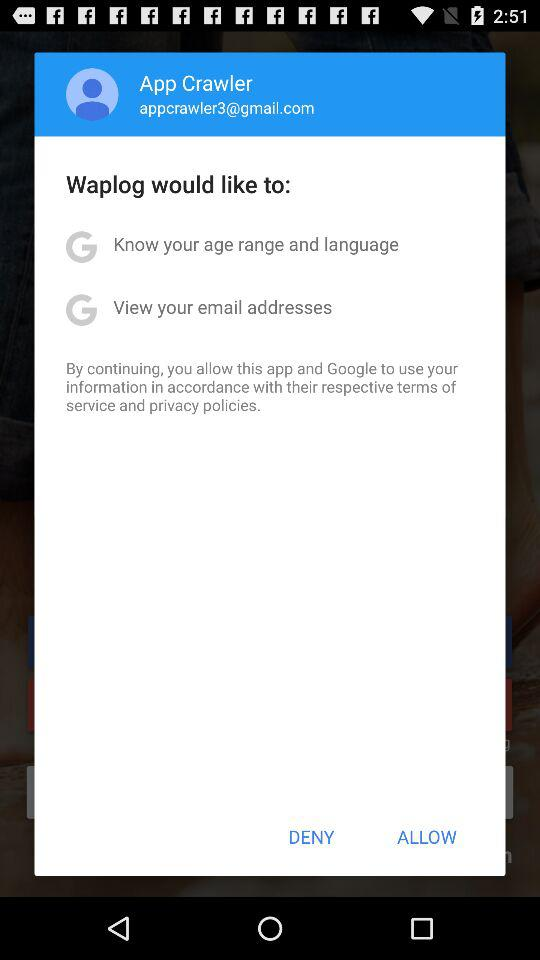What is the email Address? The email address is appcrawler3@gmail.com. 